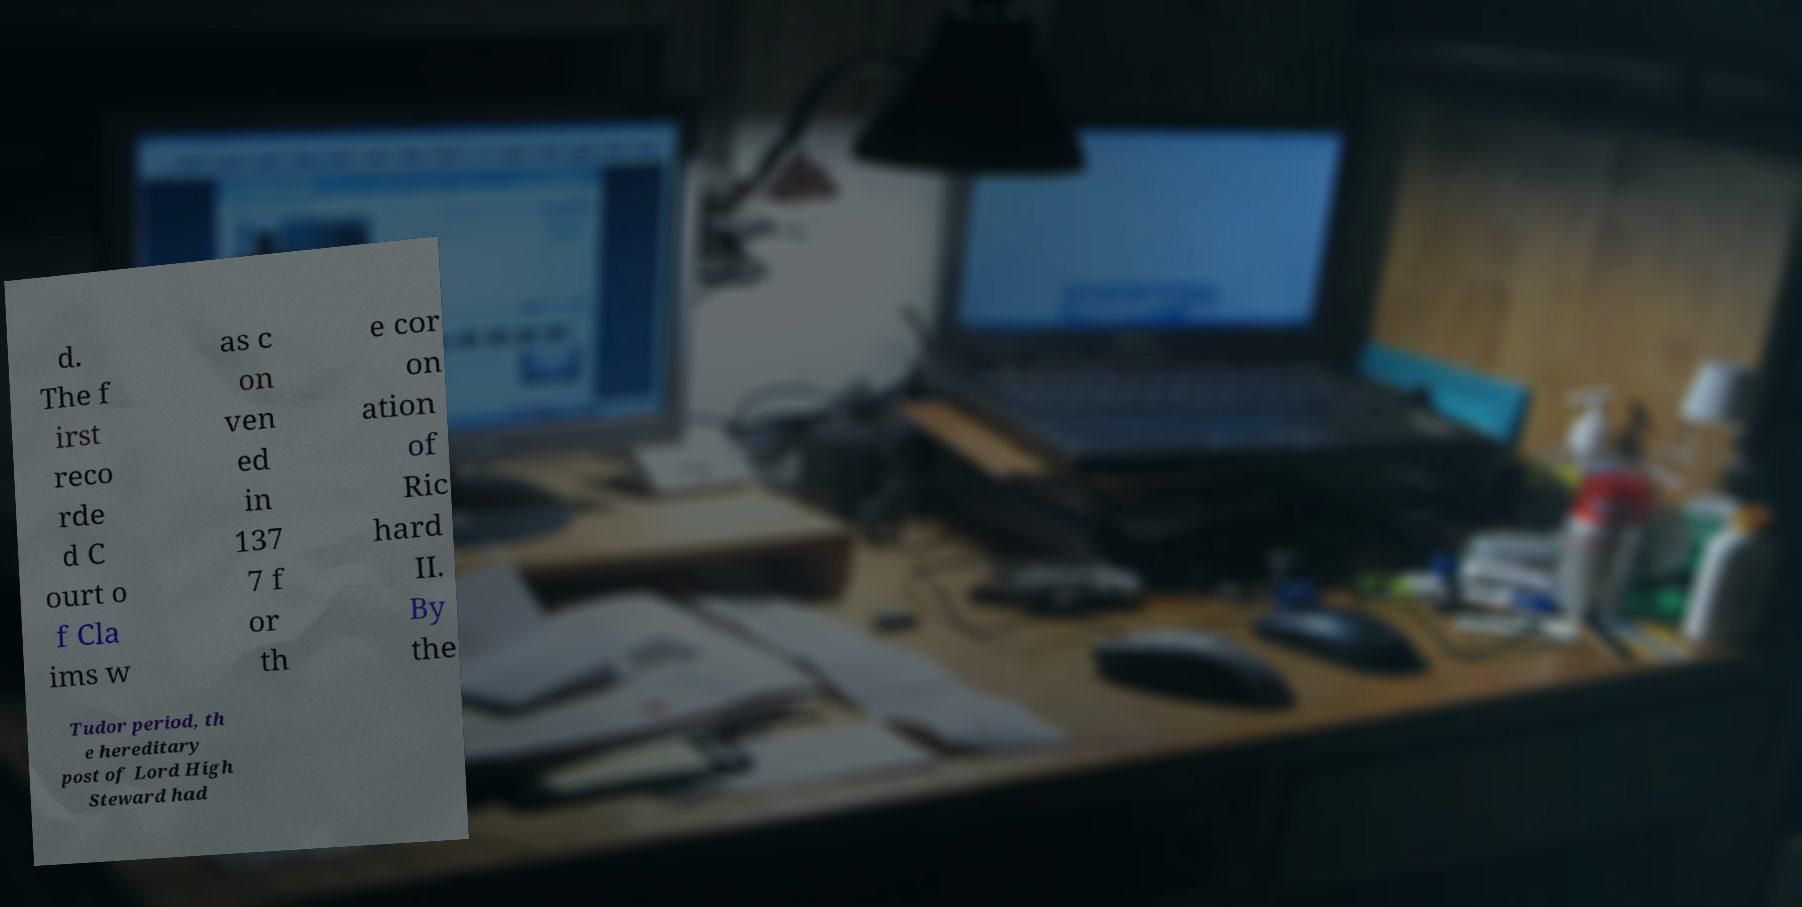What messages or text are displayed in this image? I need them in a readable, typed format. d. The f irst reco rde d C ourt o f Cla ims w as c on ven ed in 137 7 f or th e cor on ation of Ric hard II. By the Tudor period, th e hereditary post of Lord High Steward had 